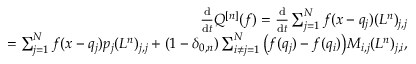Convert formula to latex. <formula><loc_0><loc_0><loc_500><loc_500>\begin{array} { r l r } & { \frac { d } { d t } Q ^ { [ n ] } ( f ) = \frac { d } { d t } \sum _ { j = 1 } ^ { N } f ( x - q _ { j } ) ( L ^ { n } ) _ { j , j } } \\ & { = \sum _ { j = 1 } ^ { N } f ( x - q _ { j } ) p _ { j } ( L ^ { n } ) _ { j , j } + ( 1 - \delta _ { 0 , n } ) \sum _ { i \neq j = 1 } ^ { N } \left ( f ( q _ { j } ) - f ( q _ { i } ) \right ) M _ { i , j } ( L ^ { n } ) _ { j , i } , } \end{array}</formula> 